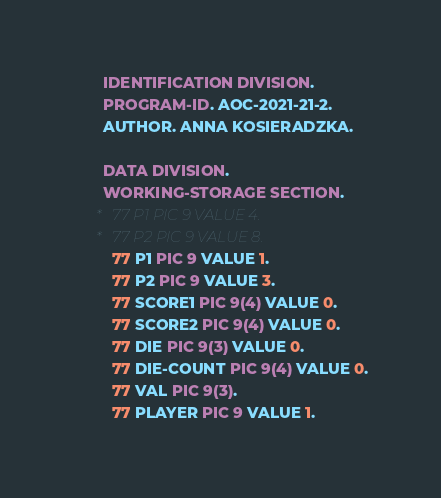Convert code to text. <code><loc_0><loc_0><loc_500><loc_500><_COBOL_>       IDENTIFICATION DIVISION.
       PROGRAM-ID. AOC-2021-21-2.
       AUTHOR. ANNA KOSIERADZKA.

       DATA DIVISION.
       WORKING-STORAGE SECTION.
      *   77 P1 PIC 9 VALUE 4.
      *   77 P2 PIC 9 VALUE 8.
         77 P1 PIC 9 VALUE 1.
         77 P2 PIC 9 VALUE 3.
         77 SCORE1 PIC 9(4) VALUE 0.
         77 SCORE2 PIC 9(4) VALUE 0.
         77 DIE PIC 9(3) VALUE 0.
         77 DIE-COUNT PIC 9(4) VALUE 0.
         77 VAL PIC 9(3).
         77 PLAYER PIC 9 VALUE 1.</code> 